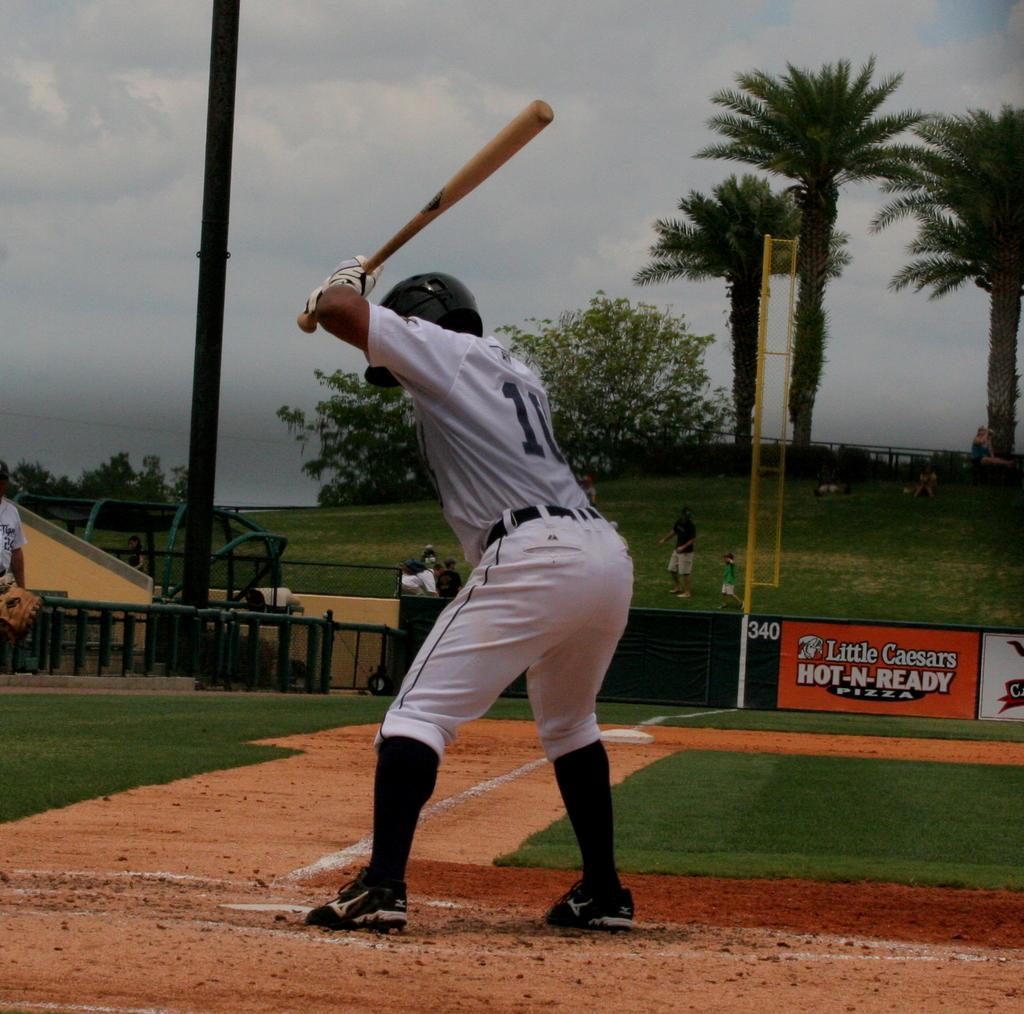What type of ad is on the outfield?
Ensure brevity in your answer.  Hot n ready pizza. What is the first number on the mans jersey?
Keep it short and to the point. 1. 